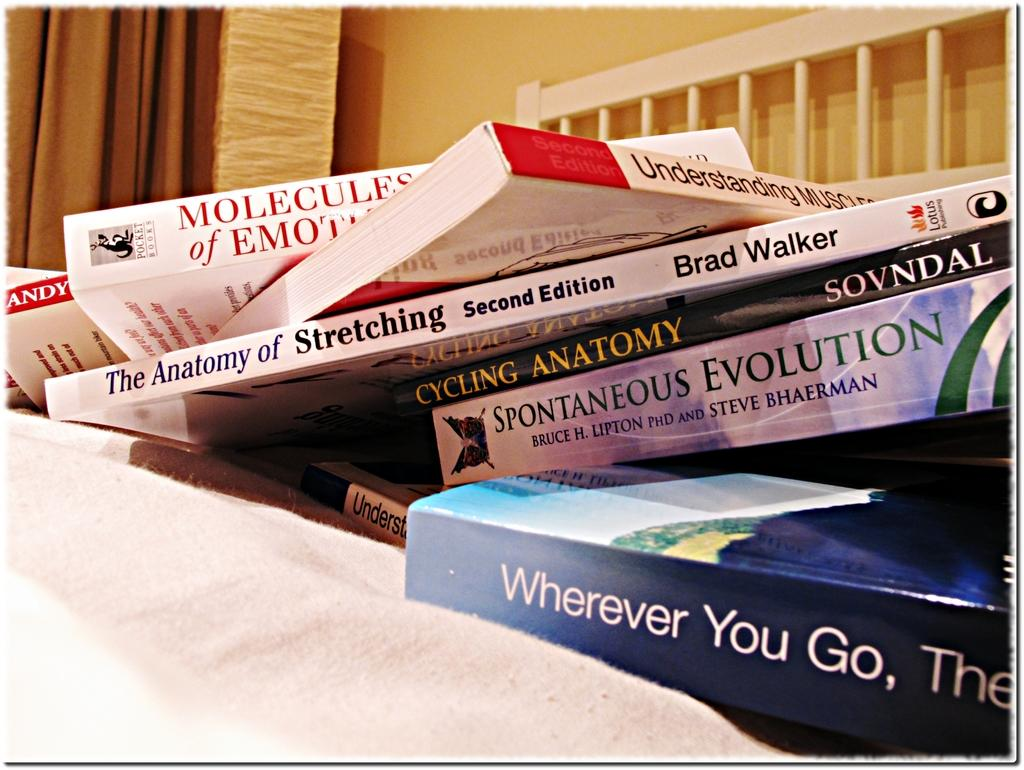<image>
Relay a brief, clear account of the picture shown. An untidy pile of books includes one entitled Spontaneous Evolution. 